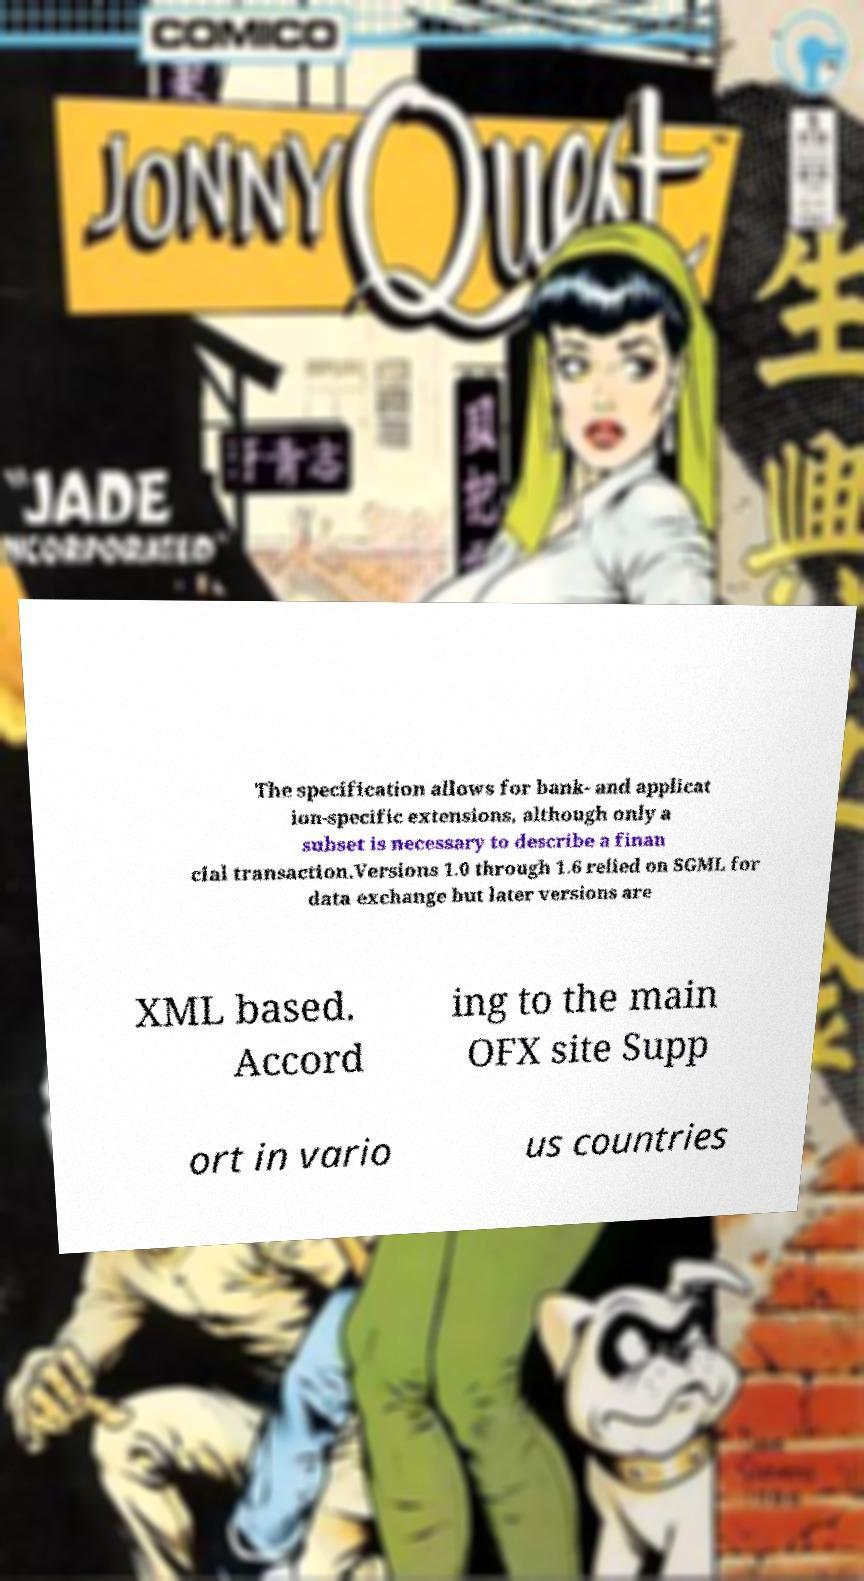Please read and relay the text visible in this image. What does it say? The specification allows for bank- and applicat ion-specific extensions, although only a subset is necessary to describe a finan cial transaction.Versions 1.0 through 1.6 relied on SGML for data exchange but later versions are XML based. Accord ing to the main OFX site Supp ort in vario us countries 